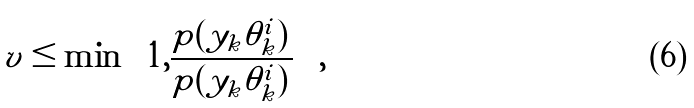<formula> <loc_0><loc_0><loc_500><loc_500>v \leq \min \left \{ 1 , \frac { p ( y _ { k } | \tilde { \theta } _ { k } ^ { i } ) } { p ( y _ { k } | \theta _ { k } ^ { i } ) } \right \} ,</formula> 